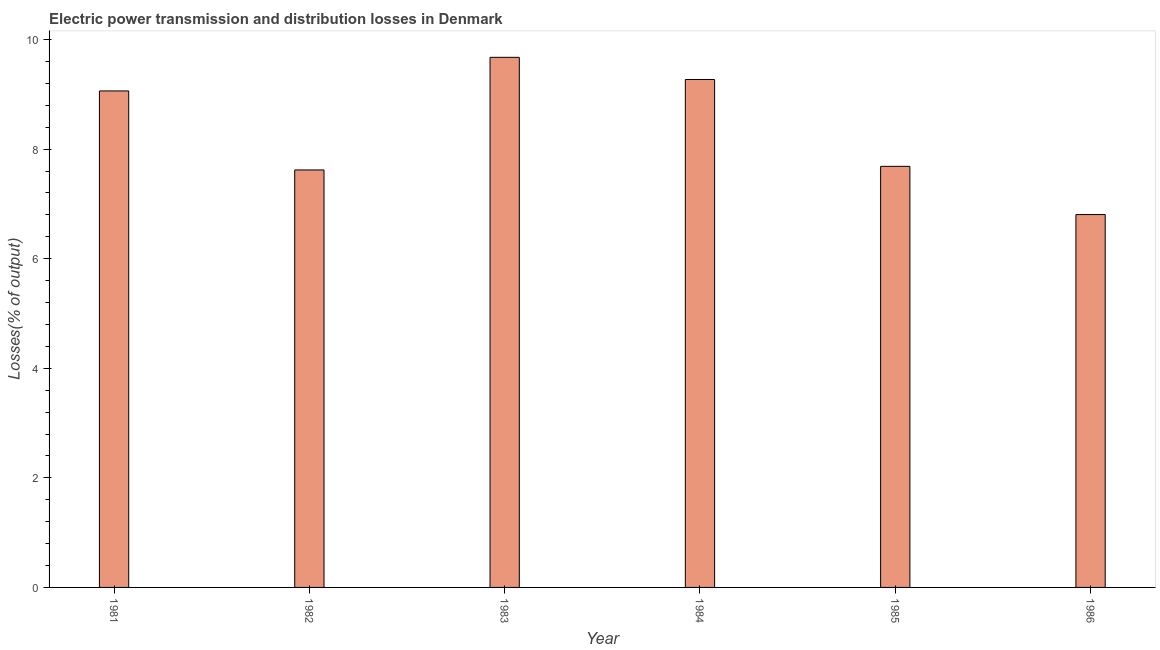Does the graph contain any zero values?
Give a very brief answer. No. What is the title of the graph?
Give a very brief answer. Electric power transmission and distribution losses in Denmark. What is the label or title of the X-axis?
Your answer should be compact. Year. What is the label or title of the Y-axis?
Keep it short and to the point. Losses(% of output). What is the electric power transmission and distribution losses in 1982?
Make the answer very short. 7.62. Across all years, what is the maximum electric power transmission and distribution losses?
Offer a terse response. 9.68. Across all years, what is the minimum electric power transmission and distribution losses?
Your response must be concise. 6.81. In which year was the electric power transmission and distribution losses minimum?
Your answer should be compact. 1986. What is the sum of the electric power transmission and distribution losses?
Make the answer very short. 50.12. What is the difference between the electric power transmission and distribution losses in 1981 and 1982?
Provide a short and direct response. 1.44. What is the average electric power transmission and distribution losses per year?
Your response must be concise. 8.35. What is the median electric power transmission and distribution losses?
Your answer should be very brief. 8.37. Do a majority of the years between 1982 and 1983 (inclusive) have electric power transmission and distribution losses greater than 8.4 %?
Make the answer very short. No. What is the ratio of the electric power transmission and distribution losses in 1981 to that in 1982?
Your response must be concise. 1.19. Is the electric power transmission and distribution losses in 1984 less than that in 1985?
Make the answer very short. No. Is the difference between the electric power transmission and distribution losses in 1983 and 1985 greater than the difference between any two years?
Give a very brief answer. No. What is the difference between the highest and the second highest electric power transmission and distribution losses?
Your answer should be very brief. 0.4. What is the difference between the highest and the lowest electric power transmission and distribution losses?
Provide a short and direct response. 2.87. Are all the bars in the graph horizontal?
Give a very brief answer. No. What is the Losses(% of output) of 1981?
Offer a terse response. 9.06. What is the Losses(% of output) of 1982?
Make the answer very short. 7.62. What is the Losses(% of output) of 1983?
Your response must be concise. 9.68. What is the Losses(% of output) of 1984?
Make the answer very short. 9.27. What is the Losses(% of output) in 1985?
Offer a very short reply. 7.69. What is the Losses(% of output) of 1986?
Keep it short and to the point. 6.81. What is the difference between the Losses(% of output) in 1981 and 1982?
Give a very brief answer. 1.44. What is the difference between the Losses(% of output) in 1981 and 1983?
Offer a terse response. -0.61. What is the difference between the Losses(% of output) in 1981 and 1984?
Make the answer very short. -0.21. What is the difference between the Losses(% of output) in 1981 and 1985?
Keep it short and to the point. 1.38. What is the difference between the Losses(% of output) in 1981 and 1986?
Offer a very short reply. 2.26. What is the difference between the Losses(% of output) in 1982 and 1983?
Your answer should be compact. -2.06. What is the difference between the Losses(% of output) in 1982 and 1984?
Your response must be concise. -1.65. What is the difference between the Losses(% of output) in 1982 and 1985?
Your answer should be very brief. -0.07. What is the difference between the Losses(% of output) in 1982 and 1986?
Offer a terse response. 0.81. What is the difference between the Losses(% of output) in 1983 and 1984?
Your answer should be very brief. 0.4. What is the difference between the Losses(% of output) in 1983 and 1985?
Provide a short and direct response. 1.99. What is the difference between the Losses(% of output) in 1983 and 1986?
Your answer should be very brief. 2.87. What is the difference between the Losses(% of output) in 1984 and 1985?
Your answer should be very brief. 1.59. What is the difference between the Losses(% of output) in 1984 and 1986?
Provide a succinct answer. 2.47. What is the difference between the Losses(% of output) in 1985 and 1986?
Offer a terse response. 0.88. What is the ratio of the Losses(% of output) in 1981 to that in 1982?
Make the answer very short. 1.19. What is the ratio of the Losses(% of output) in 1981 to that in 1983?
Ensure brevity in your answer.  0.94. What is the ratio of the Losses(% of output) in 1981 to that in 1985?
Provide a short and direct response. 1.18. What is the ratio of the Losses(% of output) in 1981 to that in 1986?
Offer a very short reply. 1.33. What is the ratio of the Losses(% of output) in 1982 to that in 1983?
Keep it short and to the point. 0.79. What is the ratio of the Losses(% of output) in 1982 to that in 1984?
Provide a short and direct response. 0.82. What is the ratio of the Losses(% of output) in 1982 to that in 1986?
Offer a terse response. 1.12. What is the ratio of the Losses(% of output) in 1983 to that in 1984?
Your response must be concise. 1.04. What is the ratio of the Losses(% of output) in 1983 to that in 1985?
Your answer should be very brief. 1.26. What is the ratio of the Losses(% of output) in 1983 to that in 1986?
Offer a terse response. 1.42. What is the ratio of the Losses(% of output) in 1984 to that in 1985?
Your answer should be very brief. 1.21. What is the ratio of the Losses(% of output) in 1984 to that in 1986?
Give a very brief answer. 1.36. What is the ratio of the Losses(% of output) in 1985 to that in 1986?
Offer a terse response. 1.13. 